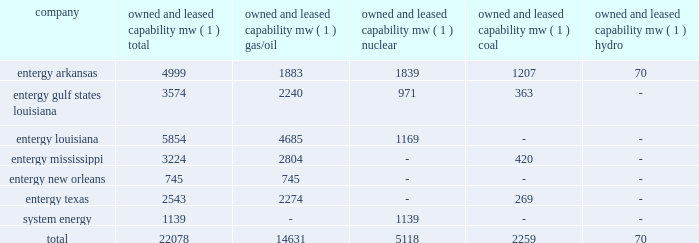Part i item 1 entergy corporation , utility operating companies , and system energy louisiana parishes in which it holds non-exclusive franchises .
Entergy louisiana's electric franchises expire during 2009-2036 .
Entergy mississippi has received from the mpsc certificates of public convenience and necessity to provide electric service to areas within 45 counties , including a number of municipalities , in western mississippi .
Under mississippi statutory law , such certificates are exclusive .
Entergy mississippi may continue to serve in such municipalities upon payment of a statutory franchise fee , regardless of whether an original municipal franchise is still in existence .
Entergy new orleans provides electric and gas service in the city of new orleans pursuant to city ordinances ( except electric service in algiers , which is provided by entergy louisiana ) .
These ordinances contain a continuing option for the city of new orleans to purchase entergy new orleans' electric and gas utility properties .
Entergy texas holds a certificate of convenience and necessity from the puct to provide electric service to areas within approximately 24 counties in eastern texas , and holds non-exclusive franchises to provide electric service in approximately 65 incorporated municipalities .
Entergy texas typically is granted 50-year franchises .
Entergy texas' electric franchises expire during 2009-2045 .
The business of system energy is limited to wholesale power sales .
It has no distribution franchises .
Property and other generation resources generating stations the total capability of the generating stations owned and leased by the utility operating companies and system energy as of december 31 , 2008 , is indicated below: .
( 1 ) "owned and leased capability" is the dependable load carrying capability as demonstrated under actual operating conditions based on the primary fuel ( assuming no curtailments ) that each station was designed to utilize .
The entergy system's load and capacity projections are reviewed periodically to assess the need and timing for additional generating capacity and interconnections .
These reviews consider existing and projected demand , the availability and price of power , the location of new load , and the economy .
Summer peak load in the entergy system service territory has averaged 21039 mw from 2002-2008 .
Due to changing use patterns , peak load growth has nearly flattened while annual energy use continues to grow .
In the 2002 time period , the entergy system's long-term capacity resources , allowing for an adequate reserve margin , were approximately 3000 mw less than the total capacity required for peak period demands .
In this time period entergy met its capacity shortages almost entirely through short-term power purchases in the wholesale spot market .
In the fall of 2002 , the entergy system began a program to add new resources to its existing generation portfolio and began a process of issuing .
What portion of the total properties operated by entergy corporation are used by gas/oil stations? 
Computations: (14631 / 22078)
Answer: 0.6627. 